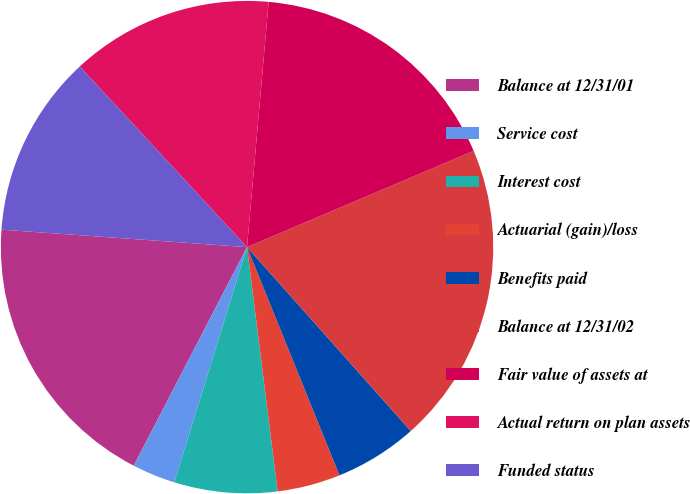<chart> <loc_0><loc_0><loc_500><loc_500><pie_chart><fcel>Balance at 12/31/01<fcel>Service cost<fcel>Interest cost<fcel>Actuarial (gain)/loss<fcel>Benefits paid<fcel>Balance at 12/31/02<fcel>Fair value of assets at<fcel>Actual return on plan assets<fcel>Funded status<nl><fcel>18.52%<fcel>2.84%<fcel>6.76%<fcel>4.14%<fcel>5.45%<fcel>19.82%<fcel>17.21%<fcel>13.29%<fcel>11.98%<nl></chart> 